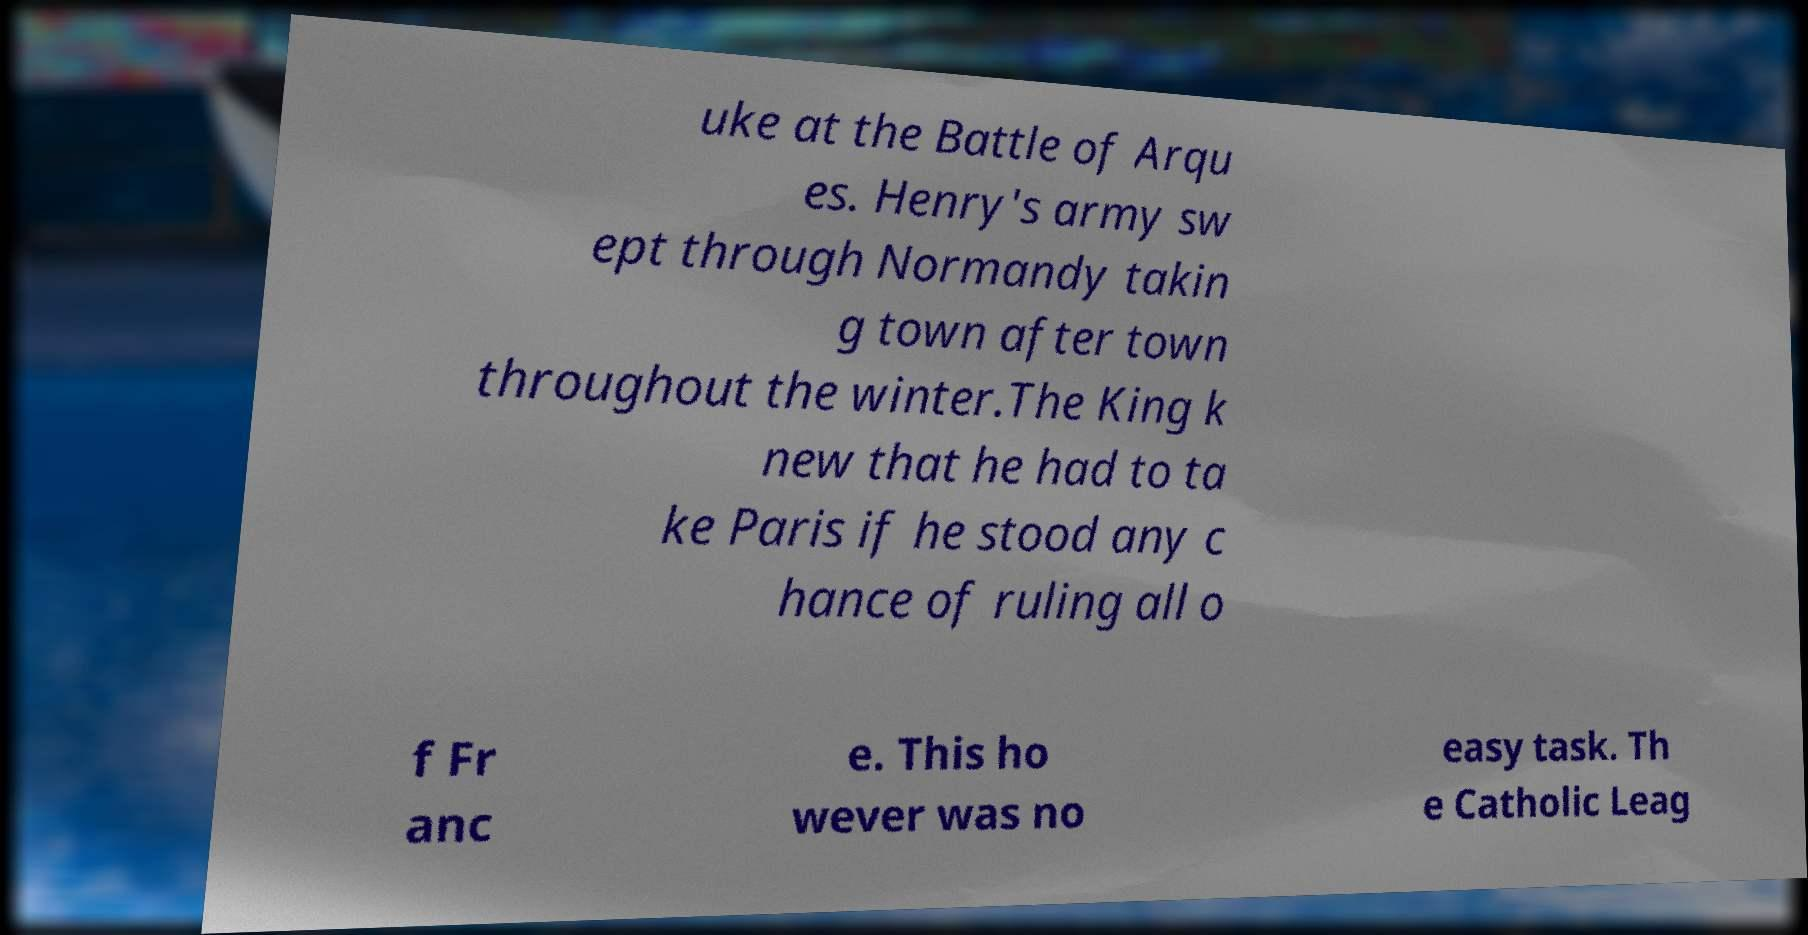There's text embedded in this image that I need extracted. Can you transcribe it verbatim? uke at the Battle of Arqu es. Henry's army sw ept through Normandy takin g town after town throughout the winter.The King k new that he had to ta ke Paris if he stood any c hance of ruling all o f Fr anc e. This ho wever was no easy task. Th e Catholic Leag 